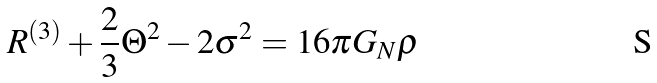Convert formula to latex. <formula><loc_0><loc_0><loc_500><loc_500>R ^ { ( 3 ) } + \frac { 2 } { 3 } \Theta ^ { 2 } - 2 \sigma ^ { 2 } = 1 6 \pi G _ { N } \rho</formula> 